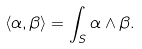Convert formula to latex. <formula><loc_0><loc_0><loc_500><loc_500>\langle \alpha , \beta \rangle = \int _ { S } \alpha \wedge \beta .</formula> 